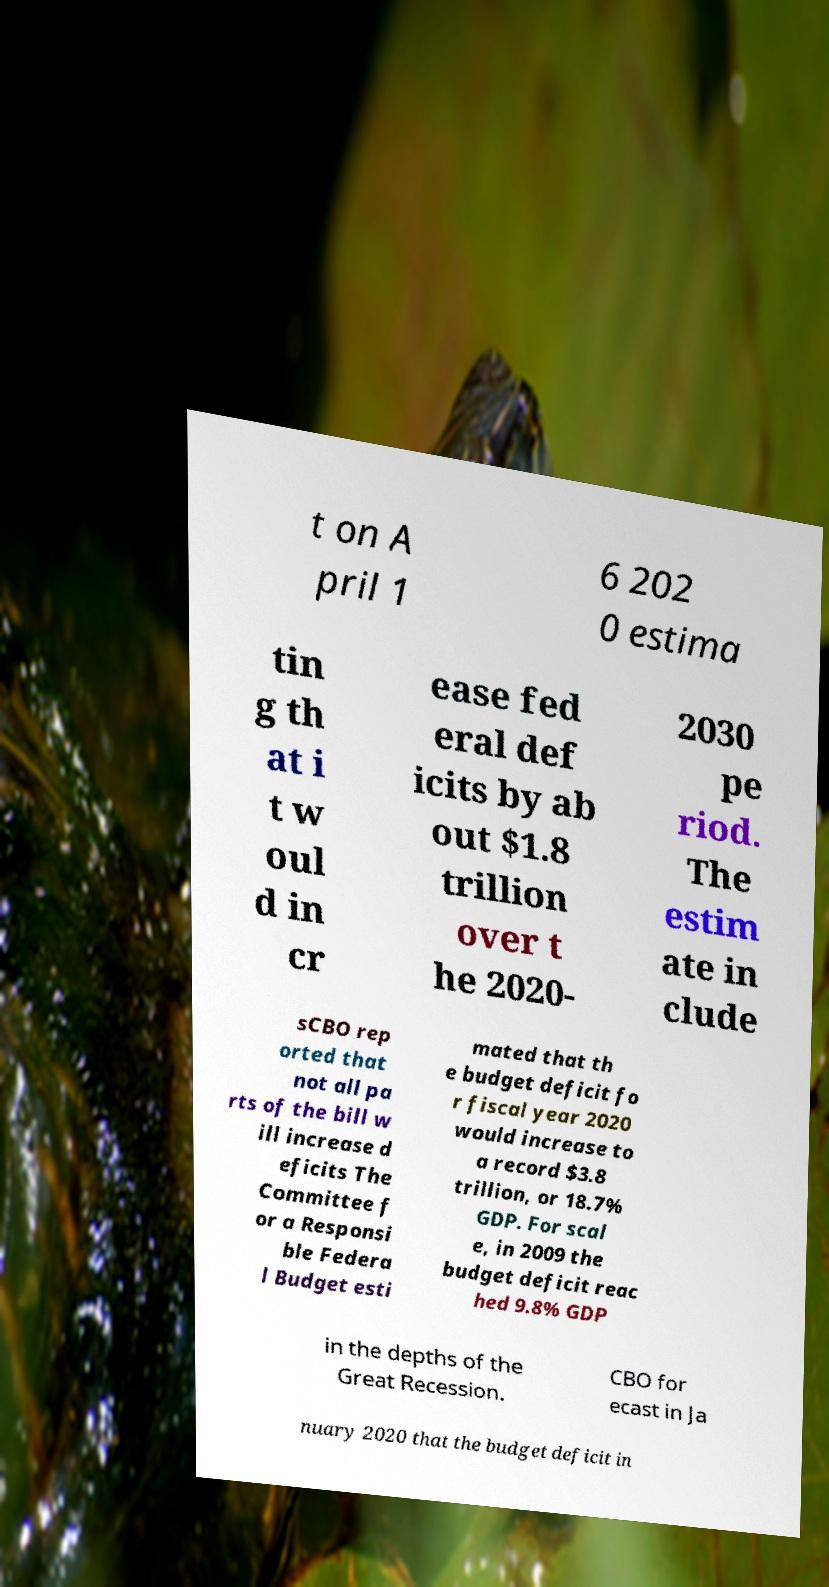What messages or text are displayed in this image? I need them in a readable, typed format. t on A pril 1 6 202 0 estima tin g th at i t w oul d in cr ease fed eral def icits by ab out $1.8 trillion over t he 2020- 2030 pe riod. The estim ate in clude sCBO rep orted that not all pa rts of the bill w ill increase d eficits The Committee f or a Responsi ble Federa l Budget esti mated that th e budget deficit fo r fiscal year 2020 would increase to a record $3.8 trillion, or 18.7% GDP. For scal e, in 2009 the budget deficit reac hed 9.8% GDP in the depths of the Great Recession. CBO for ecast in Ja nuary 2020 that the budget deficit in 